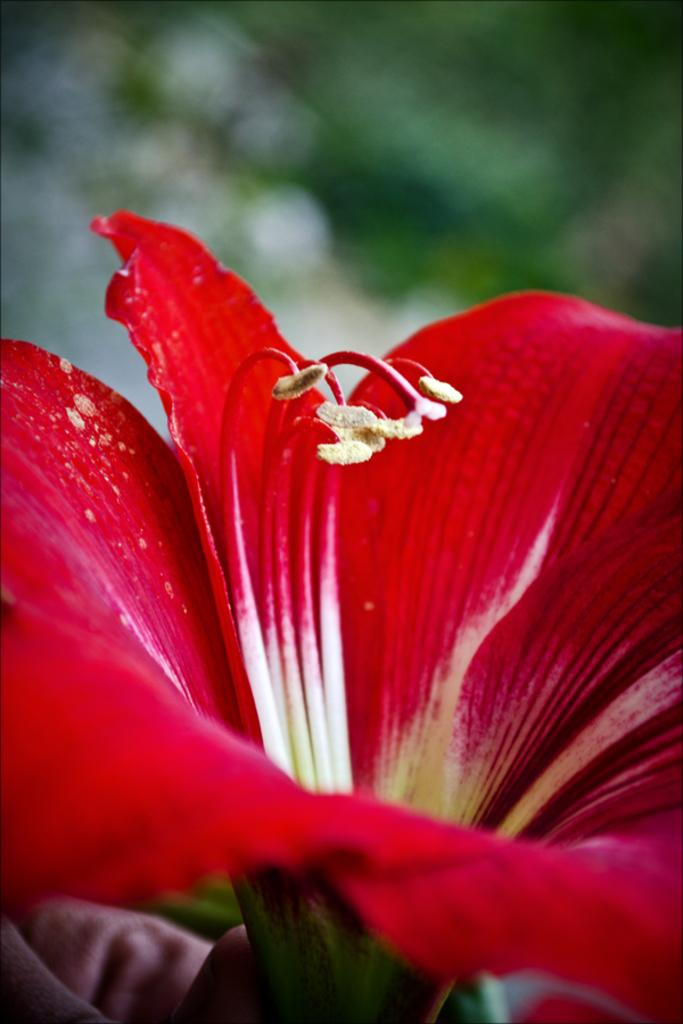What type of flower is present in the image? There is a red color flower in the image. Can you describe the color of the flower? The flower is red in color. How many dogs are visible in the image? There are no dogs present in the image; it only features a red color flower. What type of emotion does the flower display in the image? Flowers do not display emotions, so it is not possible to determine the emotion of the flower in the image. 